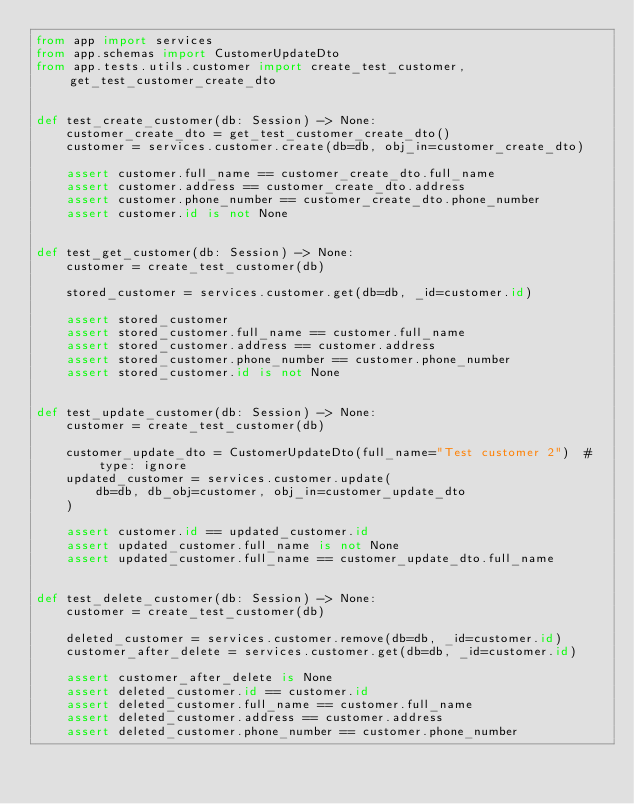Convert code to text. <code><loc_0><loc_0><loc_500><loc_500><_Python_>from app import services
from app.schemas import CustomerUpdateDto
from app.tests.utils.customer import create_test_customer, get_test_customer_create_dto


def test_create_customer(db: Session) -> None:
    customer_create_dto = get_test_customer_create_dto()
    customer = services.customer.create(db=db, obj_in=customer_create_dto)

    assert customer.full_name == customer_create_dto.full_name
    assert customer.address == customer_create_dto.address
    assert customer.phone_number == customer_create_dto.phone_number
    assert customer.id is not None


def test_get_customer(db: Session) -> None:
    customer = create_test_customer(db)

    stored_customer = services.customer.get(db=db, _id=customer.id)

    assert stored_customer
    assert stored_customer.full_name == customer.full_name
    assert stored_customer.address == customer.address
    assert stored_customer.phone_number == customer.phone_number
    assert stored_customer.id is not None


def test_update_customer(db: Session) -> None:
    customer = create_test_customer(db)

    customer_update_dto = CustomerUpdateDto(full_name="Test customer 2")  # type: ignore
    updated_customer = services.customer.update(
        db=db, db_obj=customer, obj_in=customer_update_dto
    )

    assert customer.id == updated_customer.id
    assert updated_customer.full_name is not None
    assert updated_customer.full_name == customer_update_dto.full_name


def test_delete_customer(db: Session) -> None:
    customer = create_test_customer(db)

    deleted_customer = services.customer.remove(db=db, _id=customer.id)
    customer_after_delete = services.customer.get(db=db, _id=customer.id)

    assert customer_after_delete is None
    assert deleted_customer.id == customer.id
    assert deleted_customer.full_name == customer.full_name
    assert deleted_customer.address == customer.address
    assert deleted_customer.phone_number == customer.phone_number
</code> 